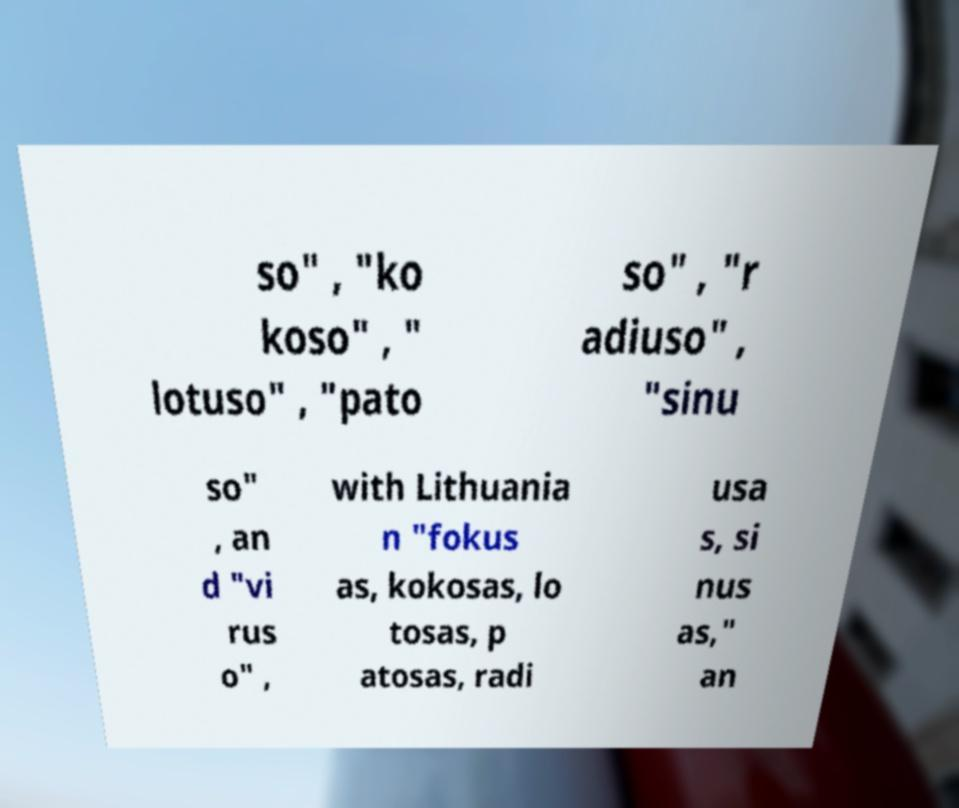Can you read and provide the text displayed in the image?This photo seems to have some interesting text. Can you extract and type it out for me? so" , "ko koso" , " lotuso" , "pato so" , "r adiuso" , "sinu so" , an d "vi rus o" , with Lithuania n "fokus as, kokosas, lo tosas, p atosas, radi usa s, si nus as," an 